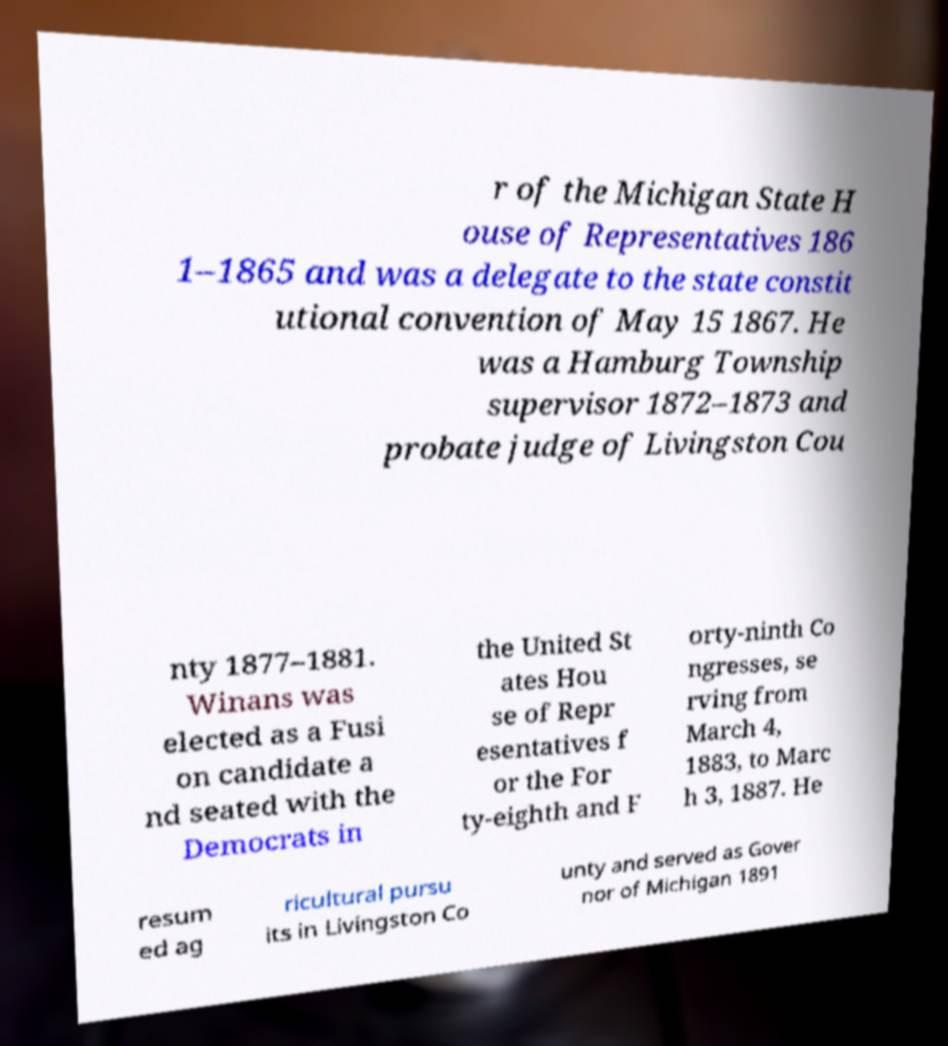For documentation purposes, I need the text within this image transcribed. Could you provide that? r of the Michigan State H ouse of Representatives 186 1–1865 and was a delegate to the state constit utional convention of May 15 1867. He was a Hamburg Township supervisor 1872–1873 and probate judge of Livingston Cou nty 1877–1881. Winans was elected as a Fusi on candidate a nd seated with the Democrats in the United St ates Hou se of Repr esentatives f or the For ty-eighth and F orty-ninth Co ngresses, se rving from March 4, 1883, to Marc h 3, 1887. He resum ed ag ricultural pursu its in Livingston Co unty and served as Gover nor of Michigan 1891 